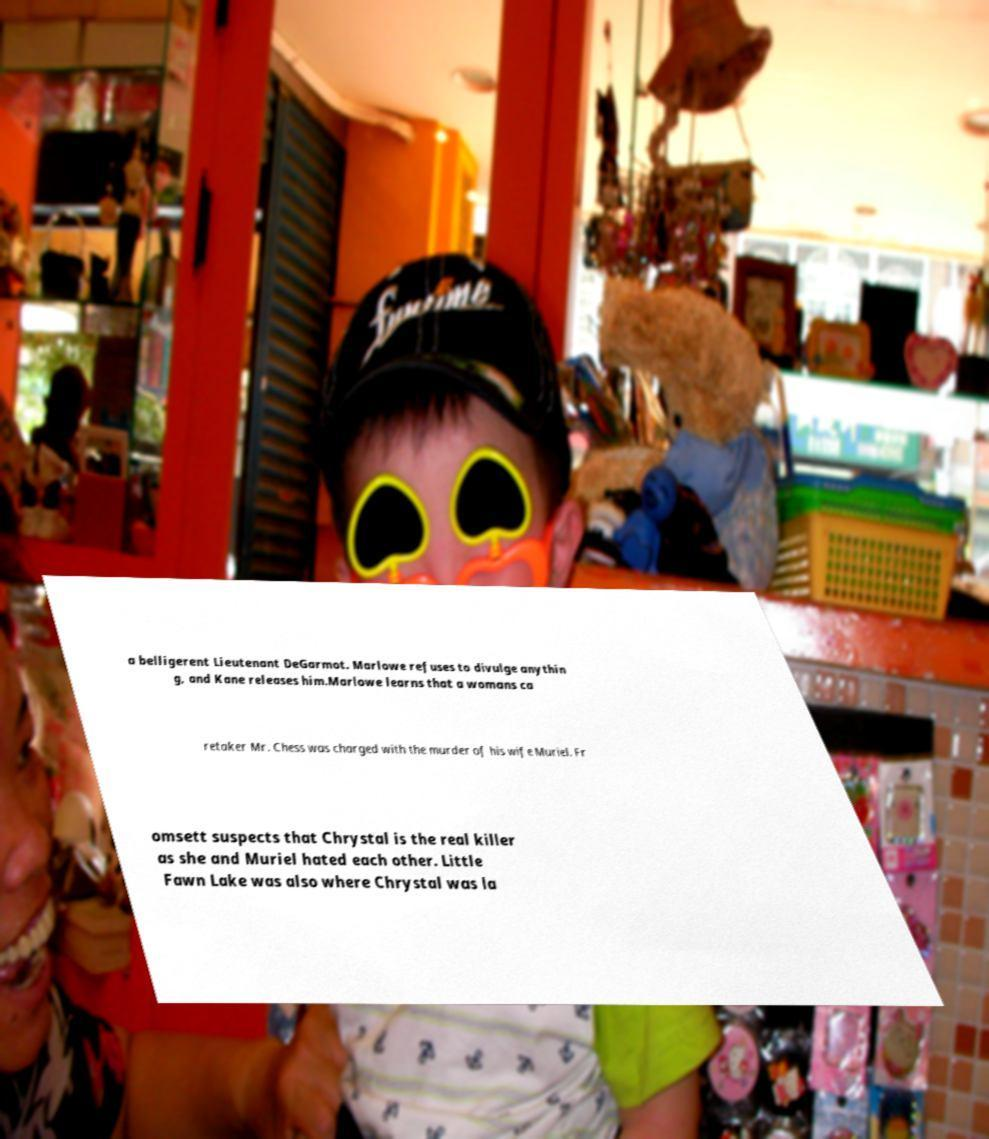Could you assist in decoding the text presented in this image and type it out clearly? a belligerent Lieutenant DeGarmot. Marlowe refuses to divulge anythin g, and Kane releases him.Marlowe learns that a womans ca retaker Mr. Chess was charged with the murder of his wife Muriel. Fr omsett suspects that Chrystal is the real killer as she and Muriel hated each other. Little Fawn Lake was also where Chrystal was la 